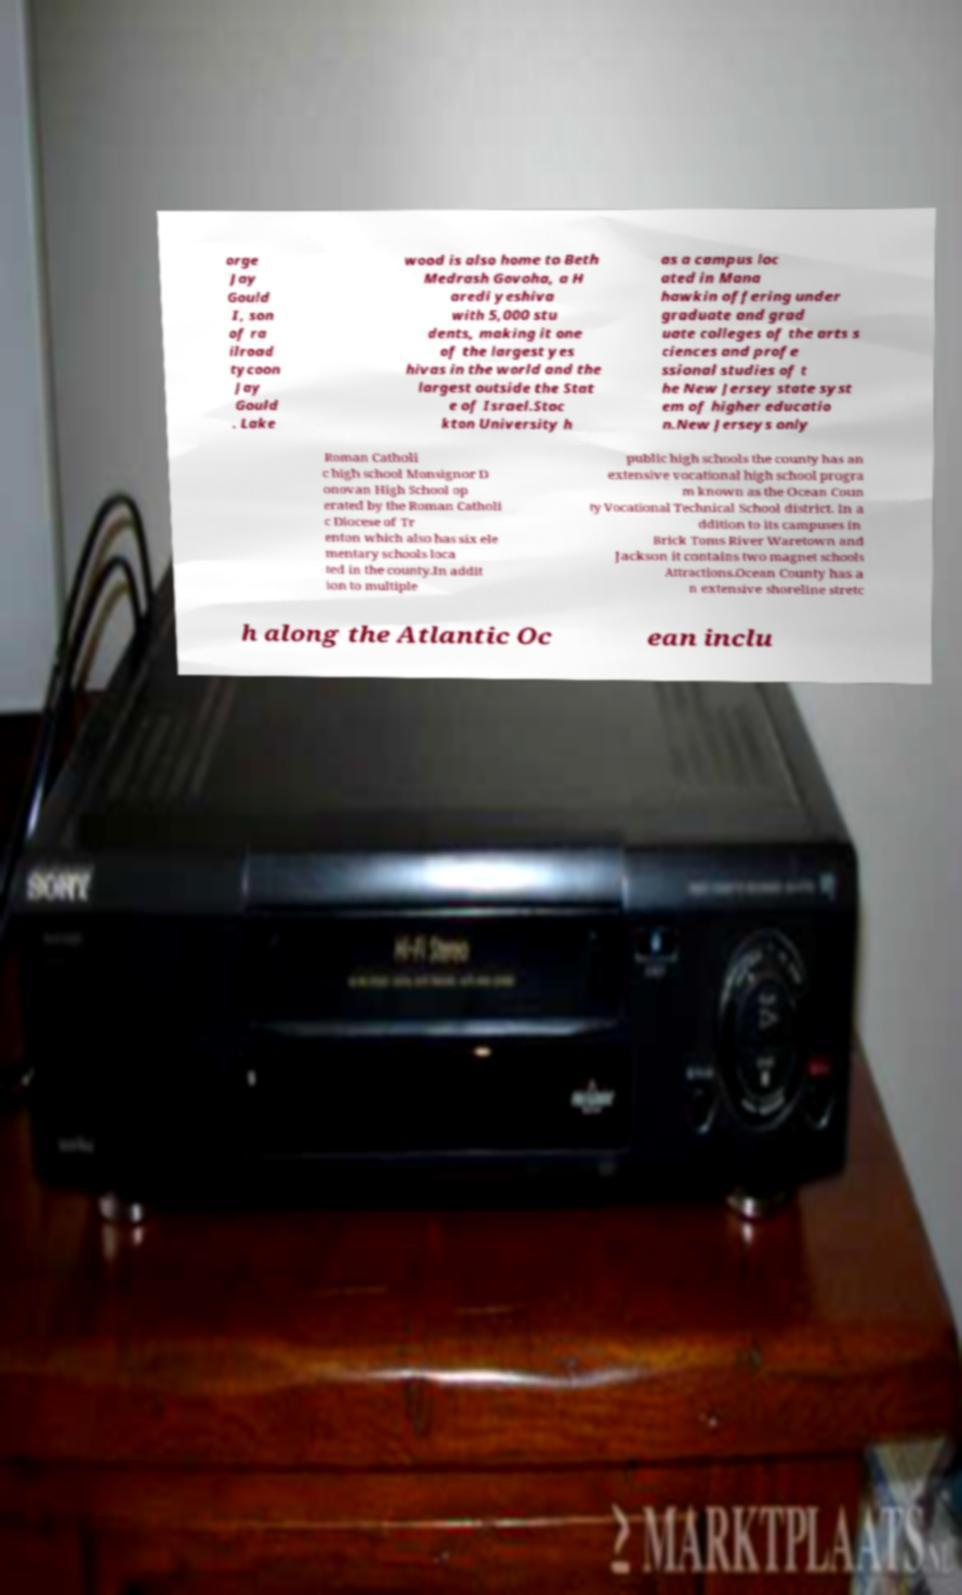I need the written content from this picture converted into text. Can you do that? orge Jay Gould I, son of ra ilroad tycoon Jay Gould . Lake wood is also home to Beth Medrash Govoha, a H aredi yeshiva with 5,000 stu dents, making it one of the largest yes hivas in the world and the largest outside the Stat e of Israel.Stoc kton University h as a campus loc ated in Mana hawkin offering under graduate and grad uate colleges of the arts s ciences and profe ssional studies of t he New Jersey state syst em of higher educatio n.New Jerseys only Roman Catholi c high school Monsignor D onovan High School op erated by the Roman Catholi c Diocese of Tr enton which also has six ele mentary schools loca ted in the county.In addit ion to multiple public high schools the county has an extensive vocational high school progra m known as the Ocean Coun ty Vocational Technical School district. In a ddition to its campuses in Brick Toms River Waretown and Jackson it contains two magnet schools Attractions.Ocean County has a n extensive shoreline stretc h along the Atlantic Oc ean inclu 